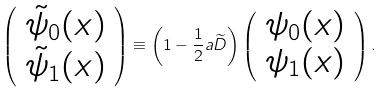Convert formula to latex. <formula><loc_0><loc_0><loc_500><loc_500>\left ( \begin{array} { c } \tilde { \psi } _ { 0 } ( x ) \\ \tilde { \psi } _ { 1 } ( x ) \end{array} \right ) \equiv \left ( 1 - \frac { 1 } { 2 } a \widetilde { D } \right ) \left ( \begin{array} { c } \psi _ { 0 } ( x ) \\ \psi _ { 1 } ( x ) \end{array} \right ) .</formula> 